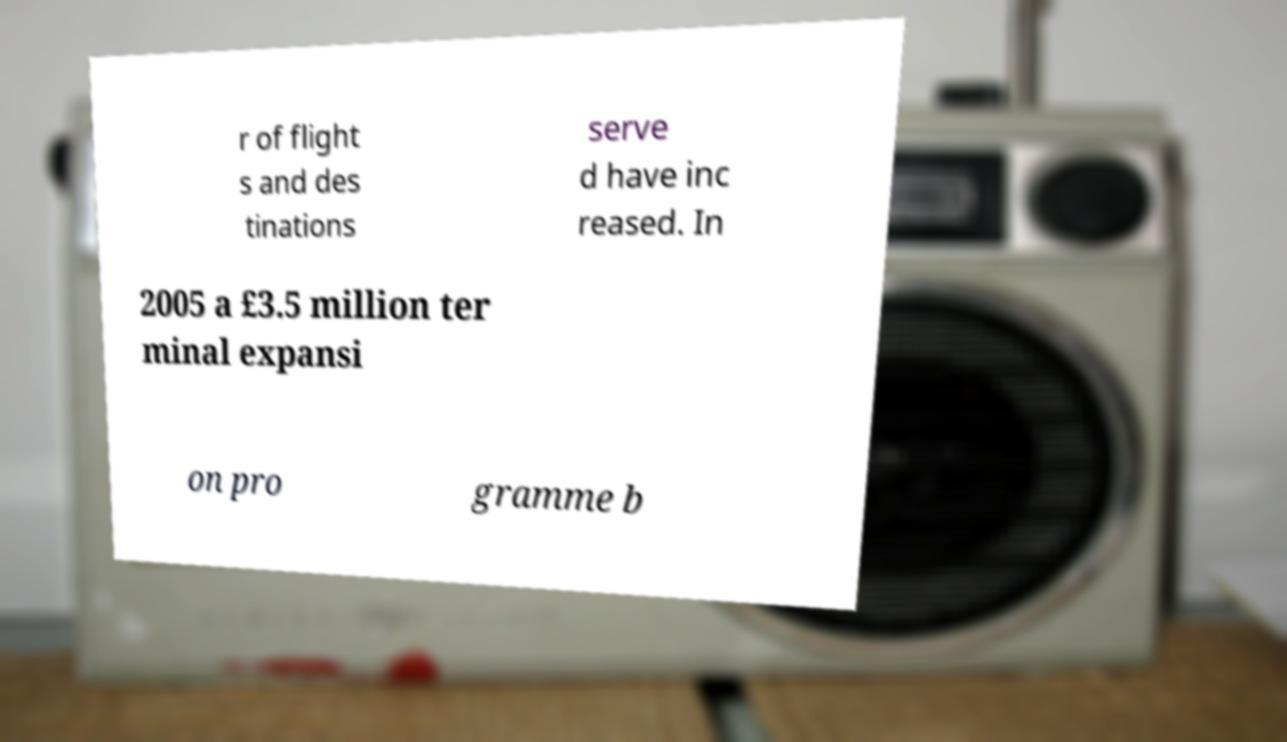Could you assist in decoding the text presented in this image and type it out clearly? r of flight s and des tinations serve d have inc reased. In 2005 a £3.5 million ter minal expansi on pro gramme b 